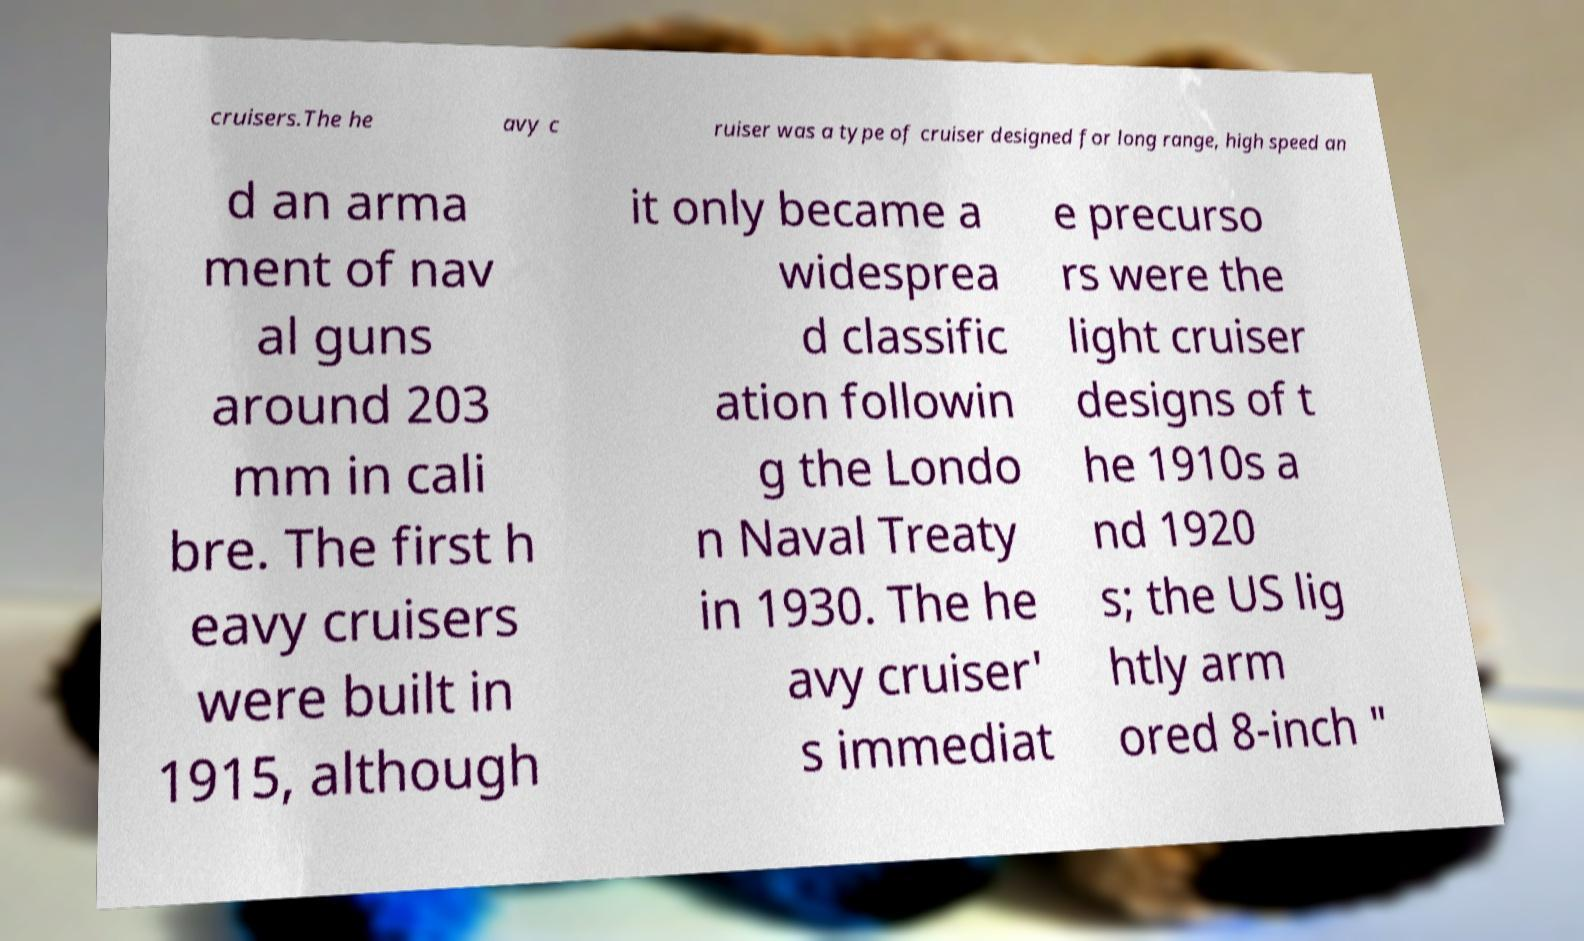Please read and relay the text visible in this image. What does it say? cruisers.The he avy c ruiser was a type of cruiser designed for long range, high speed an d an arma ment of nav al guns around 203 mm in cali bre. The first h eavy cruisers were built in 1915, although it only became a widesprea d classific ation followin g the Londo n Naval Treaty in 1930. The he avy cruiser' s immediat e precurso rs were the light cruiser designs of t he 1910s a nd 1920 s; the US lig htly arm ored 8-inch " 